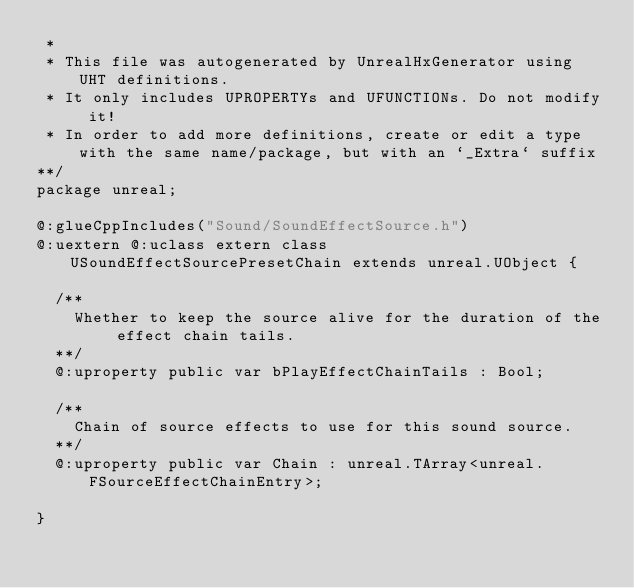Convert code to text. <code><loc_0><loc_0><loc_500><loc_500><_Haxe_> * 
 * This file was autogenerated by UnrealHxGenerator using UHT definitions.
 * It only includes UPROPERTYs and UFUNCTIONs. Do not modify it!
 * In order to add more definitions, create or edit a type with the same name/package, but with an `_Extra` suffix
**/
package unreal;

@:glueCppIncludes("Sound/SoundEffectSource.h")
@:uextern @:uclass extern class USoundEffectSourcePresetChain extends unreal.UObject {
  
  /**
    Whether to keep the source alive for the duration of the effect chain tails.
  **/
  @:uproperty public var bPlayEffectChainTails : Bool;
  
  /**
    Chain of source effects to use for this sound source.
  **/
  @:uproperty public var Chain : unreal.TArray<unreal.FSourceEffectChainEntry>;
  
}
</code> 